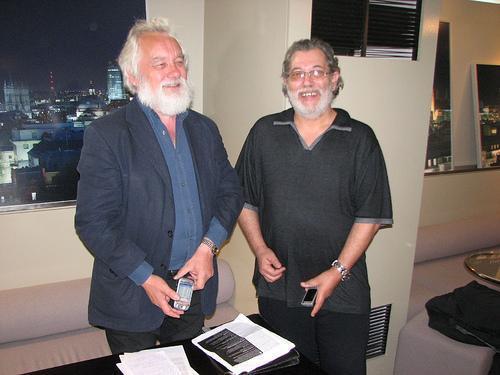How many couches are in the picture?
Give a very brief answer. 2. How many people are visible?
Give a very brief answer. 2. 